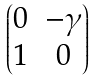<formula> <loc_0><loc_0><loc_500><loc_500>\begin{pmatrix} 0 & - \gamma \\ 1 & 0 \end{pmatrix}</formula> 